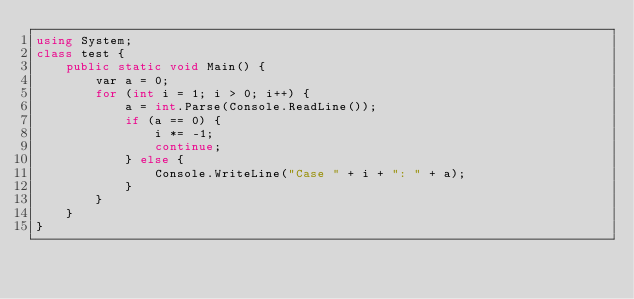Convert code to text. <code><loc_0><loc_0><loc_500><loc_500><_C#_>using System;
class test {
    public static void Main() {
        var a = 0;
        for (int i = 1; i > 0; i++) {
            a = int.Parse(Console.ReadLine());
            if (a == 0) {
                i *= -1;
                continue;
            } else {
                Console.WriteLine("Case " + i + ": " + a);
            }
        }
    }
}
</code> 